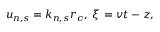Convert formula to latex. <formula><loc_0><loc_0><loc_500><loc_500>u _ { n , s } = k _ { n , s } r _ { c } , \, \xi = v t - z ,</formula> 